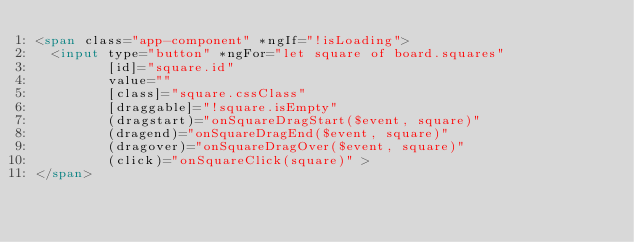Convert code to text. <code><loc_0><loc_0><loc_500><loc_500><_HTML_><span class="app-component" *ngIf="!isLoading">
  <input type="button" *ngFor="let square of board.squares"
         [id]="square.id"
         value=""
         [class]="square.cssClass"
         [draggable]="!square.isEmpty"
         (dragstart)="onSquareDragStart($event, square)"
         (dragend)="onSquareDragEnd($event, square)"
         (dragover)="onSquareDragOver($event, square)"
         (click)="onSquareClick(square)" >
</span>
</code> 